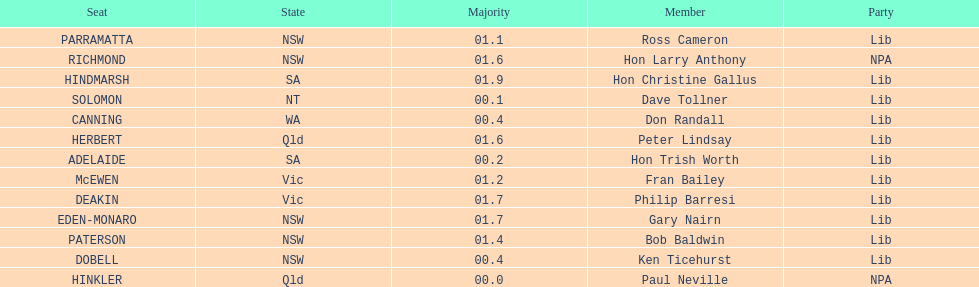How many members in total? 13. 